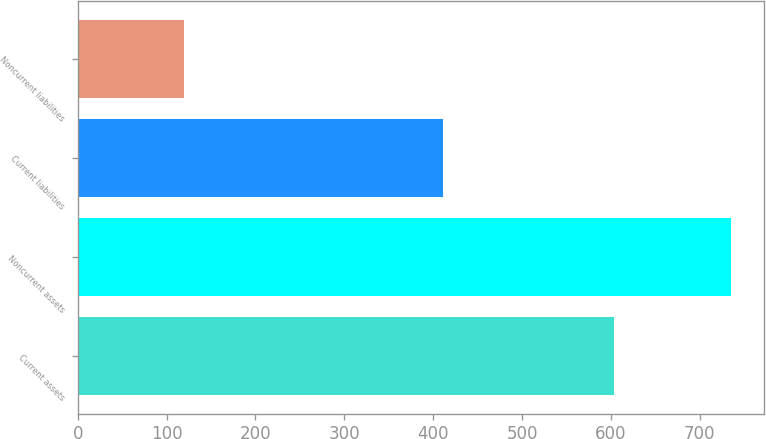<chart> <loc_0><loc_0><loc_500><loc_500><bar_chart><fcel>Current assets<fcel>Noncurrent assets<fcel>Current liabilities<fcel>Noncurrent liabilities<nl><fcel>603.1<fcel>735.3<fcel>411.2<fcel>119.7<nl></chart> 